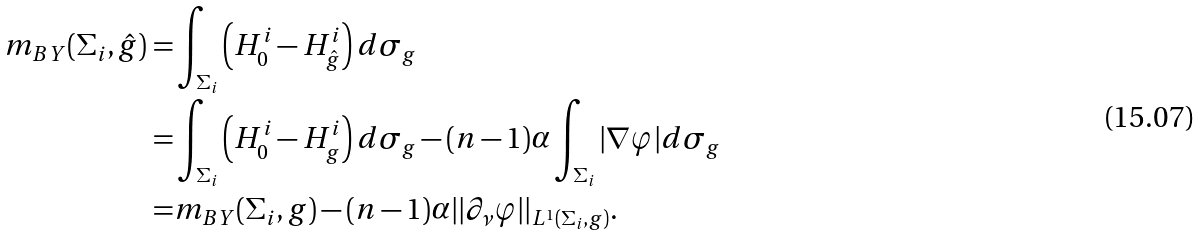<formula> <loc_0><loc_0><loc_500><loc_500>m _ { B Y } ( \Sigma _ { i } , \hat { g } ) = & \int _ { \Sigma _ { i } } \left ( H _ { 0 } ^ { i } - H _ { \hat { g } } ^ { i } \right ) d \sigma _ { g } \\ = & \int _ { \Sigma _ { i } } \left ( H _ { 0 } ^ { i } - H _ { g } ^ { i } \right ) d \sigma _ { g } - ( n - 1 ) \alpha \int _ { \Sigma _ { i } } | \nabla \varphi | d \sigma _ { g } \\ = & m _ { B Y } ( \Sigma _ { i } , g ) - ( n - 1 ) \alpha | | \partial _ { \nu } \varphi | | _ { L ^ { 1 } ( \Sigma _ { i } , g ) } .</formula> 